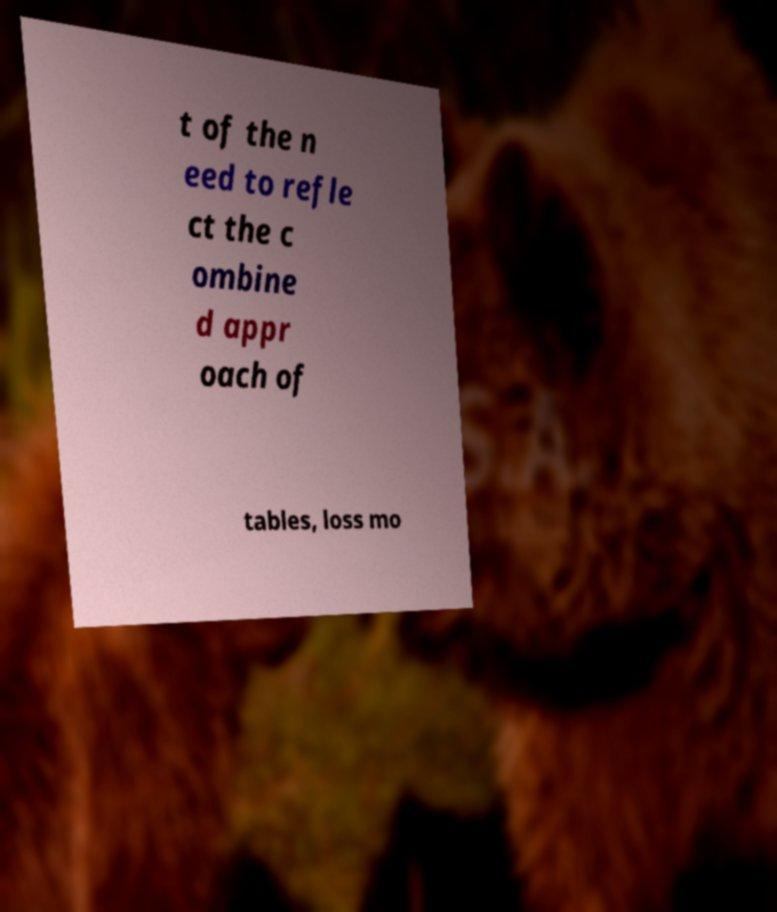There's text embedded in this image that I need extracted. Can you transcribe it verbatim? t of the n eed to refle ct the c ombine d appr oach of tables, loss mo 